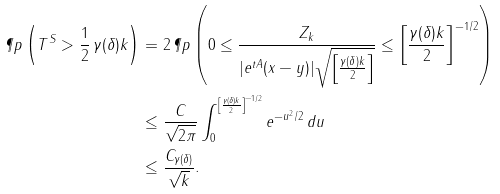<formula> <loc_0><loc_0><loc_500><loc_500>\P p \left ( T ^ { S } > \frac { 1 } { 2 } \, \gamma ( \delta ) k \right ) & = 2 \, \P p \left ( 0 \leq \frac { Z _ { k } } { | e ^ { t A } ( x - y ) | \sqrt { \left [ \frac { \gamma ( \delta ) k } { 2 } \right ] } } \leq { \left [ \frac { \gamma ( \delta ) k } { 2 } \right ] } ^ { - 1 / 2 } \right ) \\ & \leq \frac { C } { \sqrt { 2 \pi } } \int _ { 0 } ^ { { \left [ \frac { \gamma ( \delta ) k } { 2 } \right ] } ^ { - 1 / 2 } } e ^ { - u ^ { 2 } / 2 } \, d u \\ & \leq \frac { C _ { \gamma ( \delta ) } } { \sqrt { k } } .</formula> 